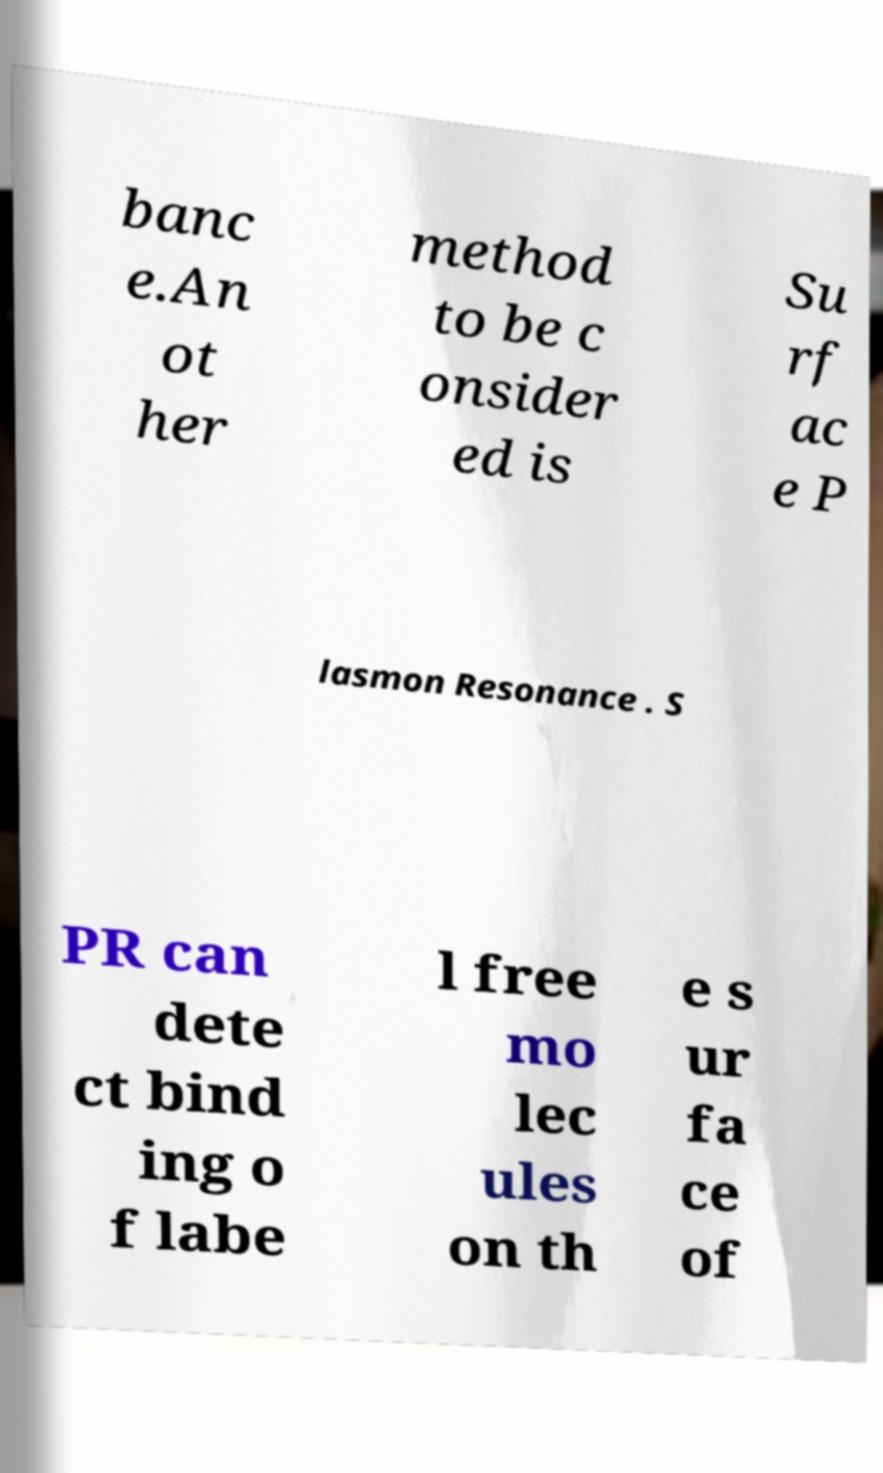What messages or text are displayed in this image? I need them in a readable, typed format. banc e.An ot her method to be c onsider ed is Su rf ac e P lasmon Resonance . S PR can dete ct bind ing o f labe l free mo lec ules on th e s ur fa ce of 